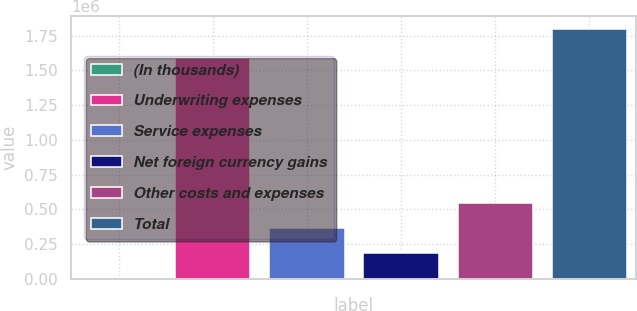Convert chart. <chart><loc_0><loc_0><loc_500><loc_500><bar_chart><fcel>(In thousands)<fcel>Underwriting expenses<fcel>Service expenses<fcel>Net foreign currency gains<fcel>Other costs and expenses<fcel>Total<nl><fcel>2012<fcel>1.59275e+06<fcel>361534<fcel>181773<fcel>541295<fcel>1.79962e+06<nl></chart> 